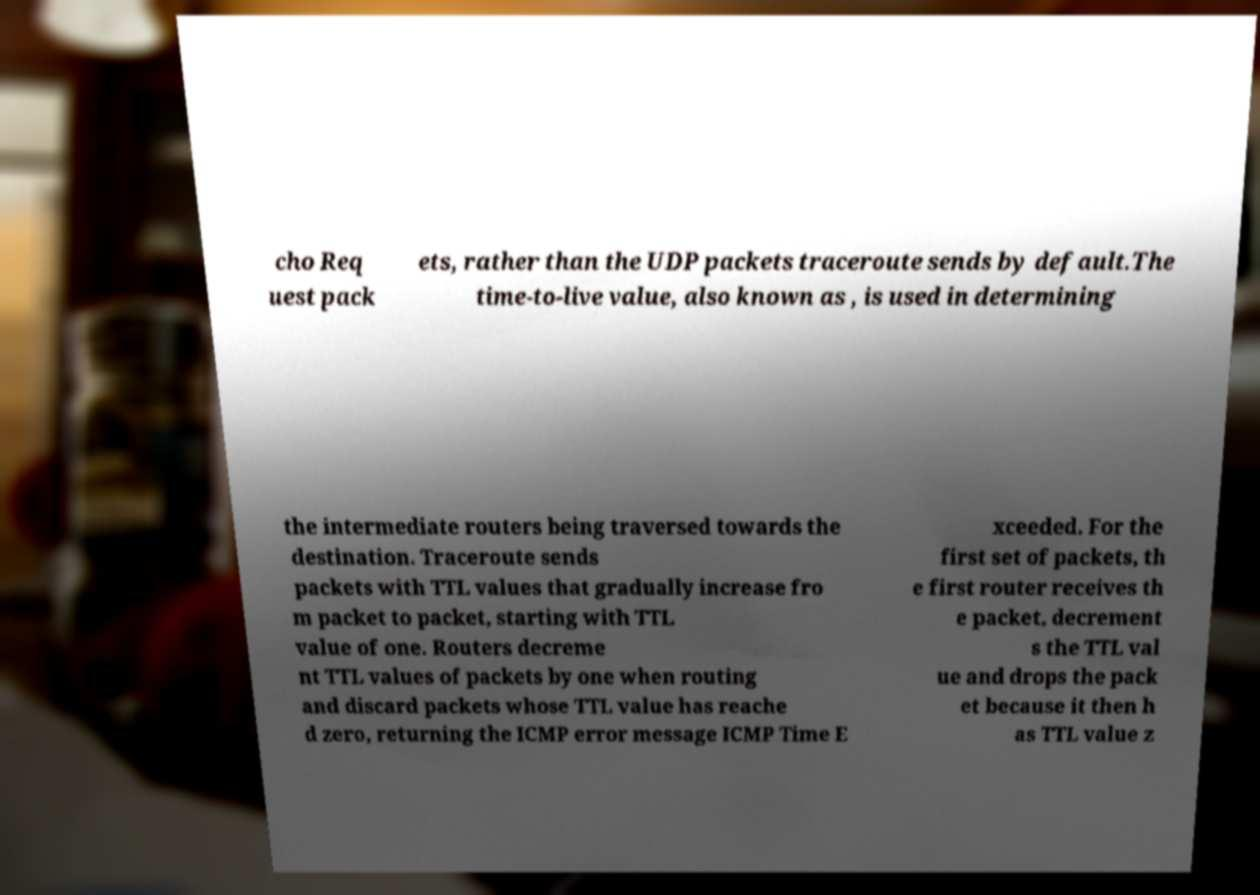I need the written content from this picture converted into text. Can you do that? cho Req uest pack ets, rather than the UDP packets traceroute sends by default.The time-to-live value, also known as , is used in determining the intermediate routers being traversed towards the destination. Traceroute sends packets with TTL values that gradually increase fro m packet to packet, starting with TTL value of one. Routers decreme nt TTL values of packets by one when routing and discard packets whose TTL value has reache d zero, returning the ICMP error message ICMP Time E xceeded. For the first set of packets, th e first router receives th e packet, decrement s the TTL val ue and drops the pack et because it then h as TTL value z 